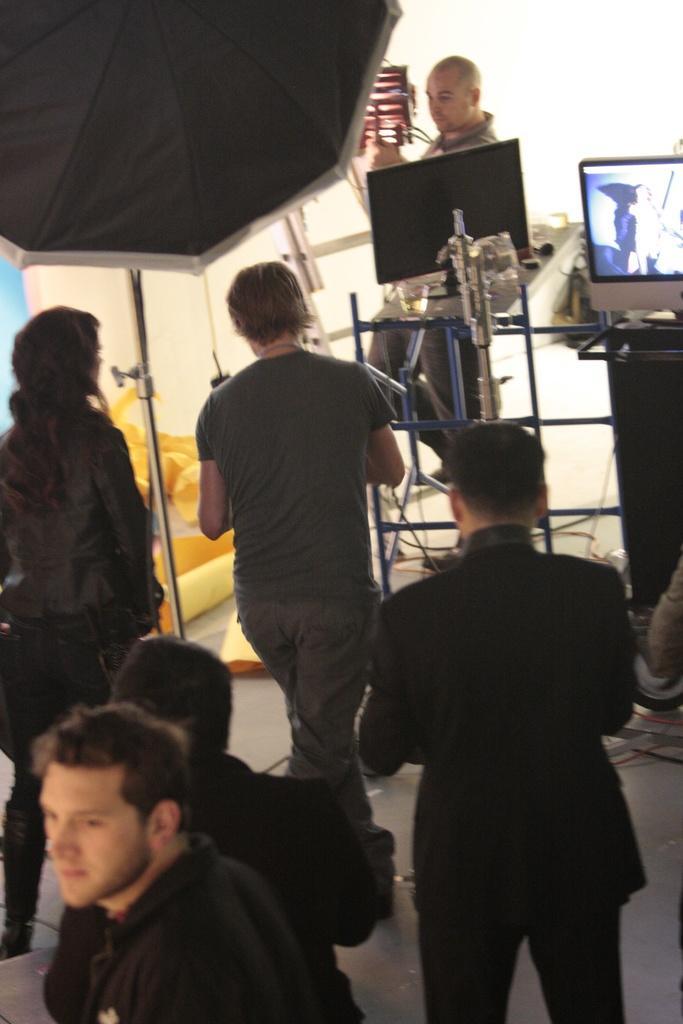How would you summarize this image in a sentence or two? In the image we can see there are many people, they are wearing clothes, this is an umbrella, screen, cable wires and this is a floor. 